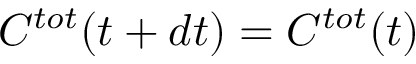<formula> <loc_0><loc_0><loc_500><loc_500>C ^ { t o t } ( t + d t ) = C ^ { t o t } ( t )</formula> 